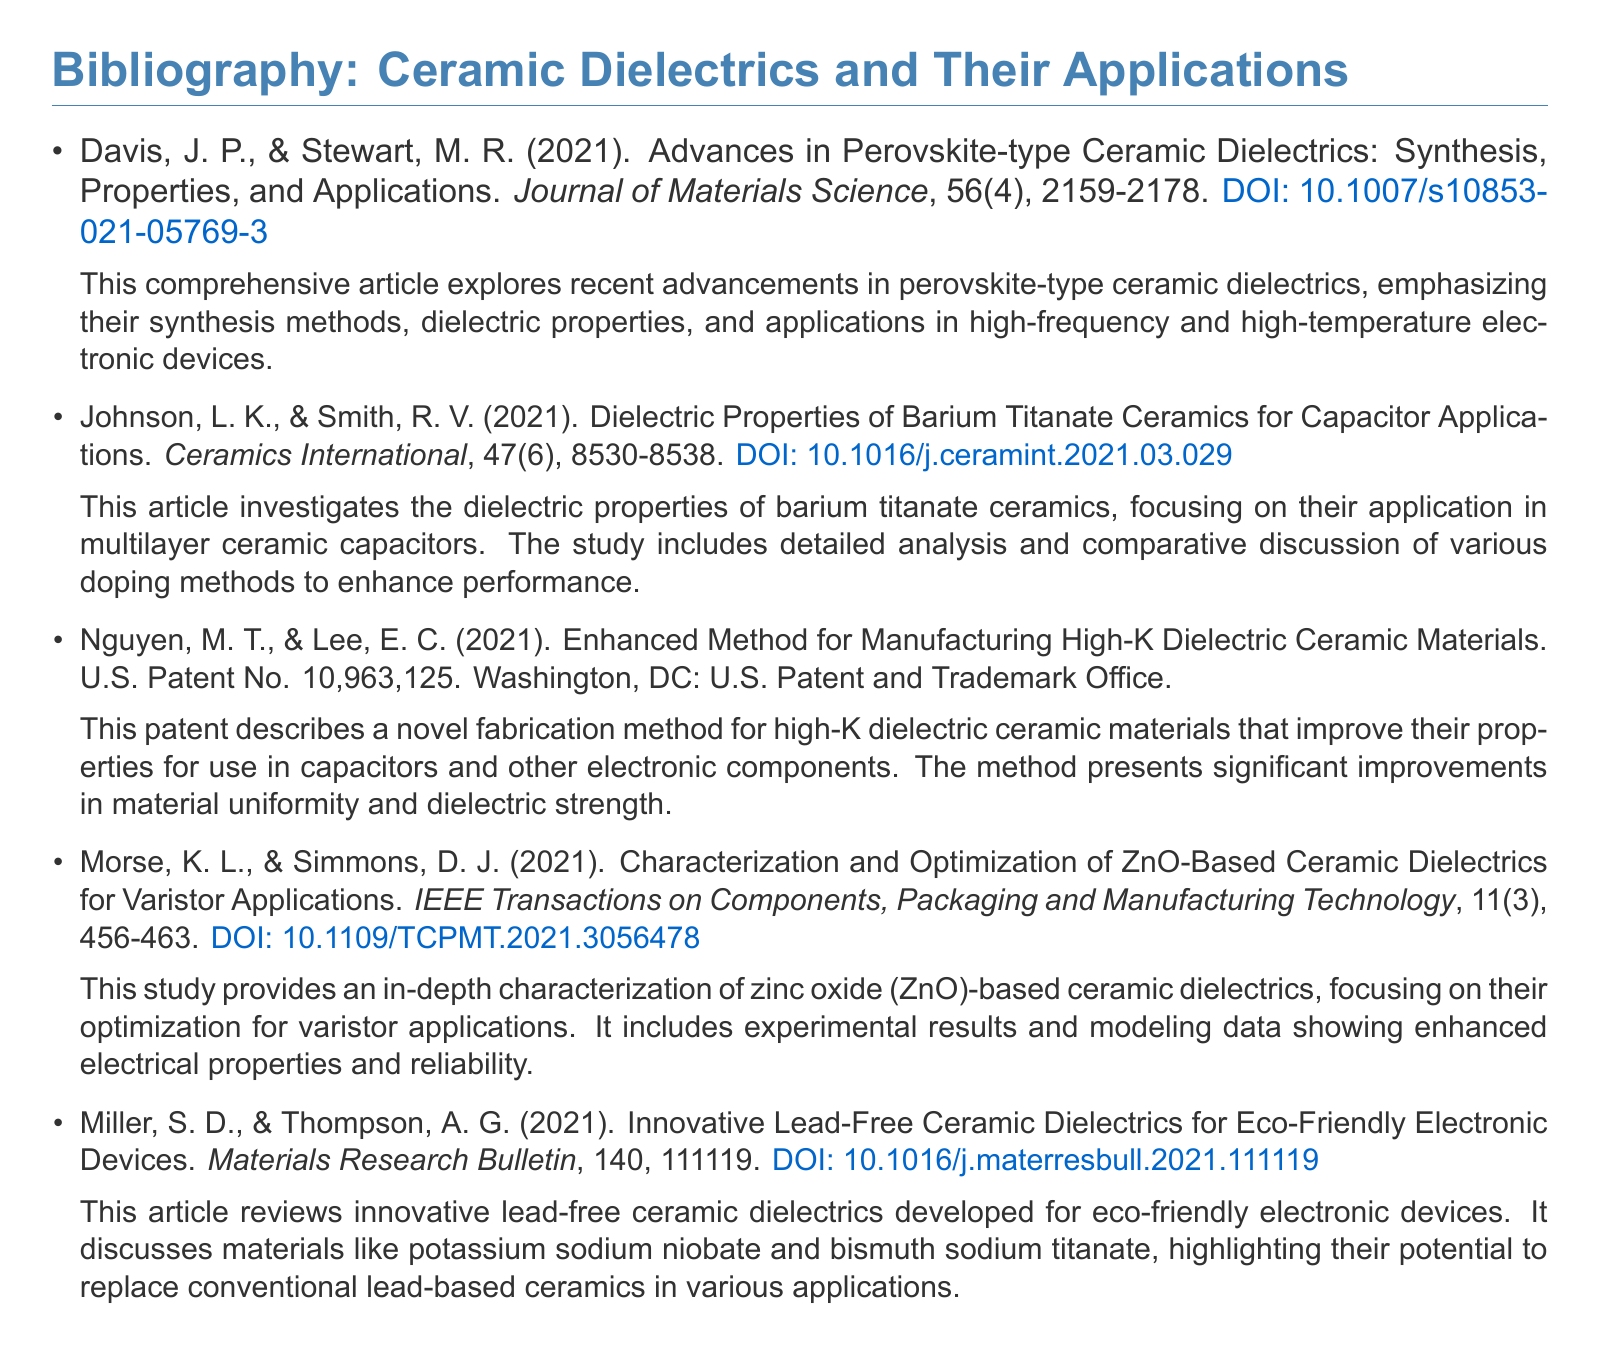What is the title of the first article listed? The title is found in the first item of the bibliography, which is "Advances in Perovskite-type Ceramic Dielectrics: Synthesis, Properties, and Applications."
Answer: Advances in Perovskite-type Ceramic Dielectrics: Synthesis, Properties, and Applications What is the DOI of the article by Johnson and Smith? The DOI can be identified in the bibliography entry for that article, which includes "DOI: 10.1016/j.ceramint.2021.03.029."
Answer: 10.1016/j.ceramint.2021.03.029 Which ceramic material is discussed in the article by Miller and Thompson? This material is specified in the title and discussion of the article, particularly mentioning "lead-free ceramic dielectrics."
Answer: lead-free ceramic dielectrics What year was the patent by Nguyen and Lee issued? The year of issuance is included in the entry, which states "U.S. Patent No. 10,963,125" in the year 2021.
Answer: 2021 What is the focus of the article by Morse and Simmons? The focus is detailed in the title and description, which mentions "characterization and optimization of ZnO-Based Ceramic Dielectrics."
Answer: optimization of ZnO-Based Ceramic Dielectrics Which journal published the article on barium titanate ceramics? The journal name appears clearly in the bibliography entry for that article, stating "Ceramics International."
Answer: Ceramics International How many authors are listed for the patent entry? The patent entry includes two authors as noted in the citation.
Answer: 2 Which material is reviewed for eco-friendly applications according to Miller and Thompson? The materials discussed in the review explicitly include "potassium sodium niobate" and "bismuth sodium titanate."
Answer: potassium sodium niobate and bismuth sodium titanate 